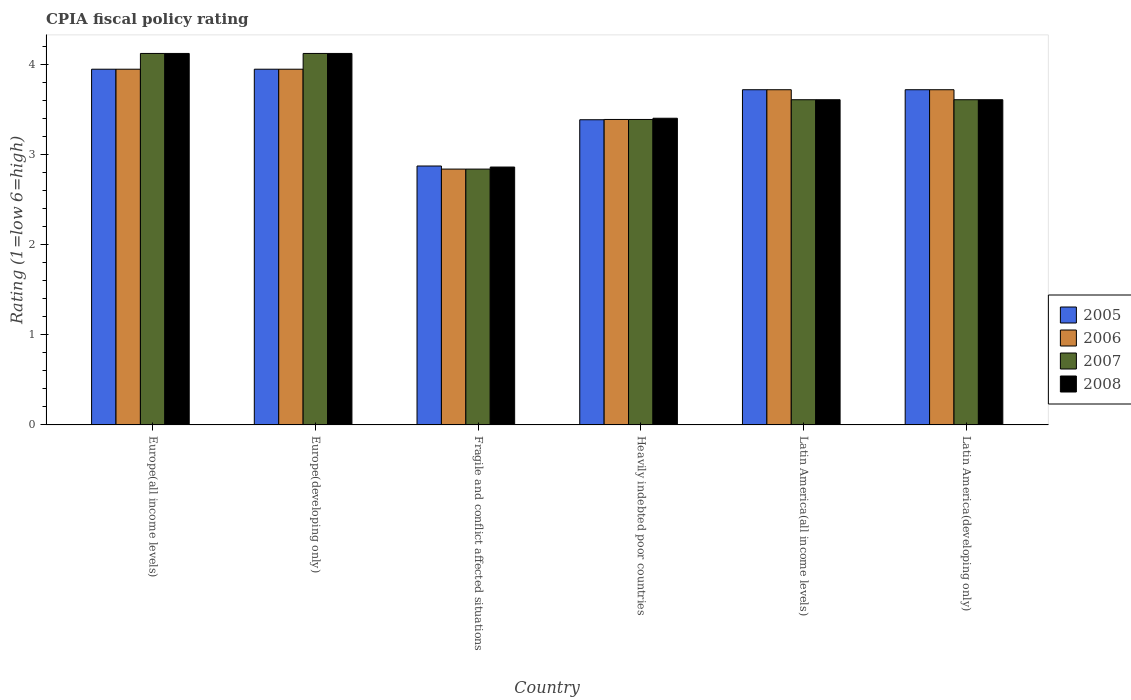How many different coloured bars are there?
Your answer should be very brief. 4. Are the number of bars on each tick of the X-axis equal?
Ensure brevity in your answer.  Yes. How many bars are there on the 4th tick from the left?
Your response must be concise. 4. How many bars are there on the 1st tick from the right?
Your answer should be very brief. 4. What is the label of the 4th group of bars from the left?
Offer a very short reply. Heavily indebted poor countries. What is the CPIA rating in 2006 in Europe(developing only)?
Your answer should be compact. 3.95. Across all countries, what is the maximum CPIA rating in 2008?
Your answer should be compact. 4.12. Across all countries, what is the minimum CPIA rating in 2007?
Offer a very short reply. 2.84. In which country was the CPIA rating in 2007 maximum?
Make the answer very short. Europe(all income levels). In which country was the CPIA rating in 2008 minimum?
Ensure brevity in your answer.  Fragile and conflict affected situations. What is the total CPIA rating in 2008 in the graph?
Ensure brevity in your answer.  21.74. What is the difference between the CPIA rating in 2007 in Fragile and conflict affected situations and that in Heavily indebted poor countries?
Your response must be concise. -0.55. What is the difference between the CPIA rating in 2007 in Latin America(all income levels) and the CPIA rating in 2006 in Heavily indebted poor countries?
Ensure brevity in your answer.  0.22. What is the average CPIA rating in 2007 per country?
Provide a succinct answer. 3.62. What is the difference between the CPIA rating of/in 2006 and CPIA rating of/in 2007 in Latin America(developing only)?
Make the answer very short. 0.11. In how many countries, is the CPIA rating in 2005 greater than 3.6?
Offer a very short reply. 4. What is the ratio of the CPIA rating in 2006 in Europe(all income levels) to that in Latin America(all income levels)?
Provide a short and direct response. 1.06. Is the difference between the CPIA rating in 2006 in Latin America(all income levels) and Latin America(developing only) greater than the difference between the CPIA rating in 2007 in Latin America(all income levels) and Latin America(developing only)?
Your answer should be compact. No. What is the difference between the highest and the second highest CPIA rating in 2006?
Provide a succinct answer. -0.23. What is the difference between the highest and the lowest CPIA rating in 2007?
Your response must be concise. 1.28. In how many countries, is the CPIA rating in 2005 greater than the average CPIA rating in 2005 taken over all countries?
Provide a short and direct response. 4. What does the 3rd bar from the left in Heavily indebted poor countries represents?
Provide a succinct answer. 2007. How many bars are there?
Your response must be concise. 24. Are all the bars in the graph horizontal?
Offer a terse response. No. How many countries are there in the graph?
Ensure brevity in your answer.  6. Where does the legend appear in the graph?
Offer a terse response. Center right. What is the title of the graph?
Ensure brevity in your answer.  CPIA fiscal policy rating. Does "1979" appear as one of the legend labels in the graph?
Make the answer very short. No. What is the label or title of the X-axis?
Your answer should be compact. Country. What is the label or title of the Y-axis?
Provide a succinct answer. Rating (1=low 6=high). What is the Rating (1=low 6=high) of 2005 in Europe(all income levels)?
Your answer should be very brief. 3.95. What is the Rating (1=low 6=high) in 2006 in Europe(all income levels)?
Your response must be concise. 3.95. What is the Rating (1=low 6=high) in 2007 in Europe(all income levels)?
Make the answer very short. 4.12. What is the Rating (1=low 6=high) in 2008 in Europe(all income levels)?
Your response must be concise. 4.12. What is the Rating (1=low 6=high) of 2005 in Europe(developing only)?
Make the answer very short. 3.95. What is the Rating (1=low 6=high) in 2006 in Europe(developing only)?
Ensure brevity in your answer.  3.95. What is the Rating (1=low 6=high) of 2007 in Europe(developing only)?
Ensure brevity in your answer.  4.12. What is the Rating (1=low 6=high) in 2008 in Europe(developing only)?
Provide a short and direct response. 4.12. What is the Rating (1=low 6=high) of 2005 in Fragile and conflict affected situations?
Offer a very short reply. 2.88. What is the Rating (1=low 6=high) of 2006 in Fragile and conflict affected situations?
Provide a succinct answer. 2.84. What is the Rating (1=low 6=high) in 2007 in Fragile and conflict affected situations?
Your answer should be very brief. 2.84. What is the Rating (1=low 6=high) in 2008 in Fragile and conflict affected situations?
Keep it short and to the point. 2.86. What is the Rating (1=low 6=high) of 2005 in Heavily indebted poor countries?
Provide a succinct answer. 3.39. What is the Rating (1=low 6=high) of 2006 in Heavily indebted poor countries?
Your response must be concise. 3.39. What is the Rating (1=low 6=high) of 2007 in Heavily indebted poor countries?
Provide a short and direct response. 3.39. What is the Rating (1=low 6=high) in 2008 in Heavily indebted poor countries?
Your answer should be very brief. 3.41. What is the Rating (1=low 6=high) of 2005 in Latin America(all income levels)?
Ensure brevity in your answer.  3.72. What is the Rating (1=low 6=high) in 2006 in Latin America(all income levels)?
Your response must be concise. 3.72. What is the Rating (1=low 6=high) of 2007 in Latin America(all income levels)?
Your answer should be compact. 3.61. What is the Rating (1=low 6=high) in 2008 in Latin America(all income levels)?
Provide a succinct answer. 3.61. What is the Rating (1=low 6=high) in 2005 in Latin America(developing only)?
Offer a terse response. 3.72. What is the Rating (1=low 6=high) in 2006 in Latin America(developing only)?
Give a very brief answer. 3.72. What is the Rating (1=low 6=high) of 2007 in Latin America(developing only)?
Offer a very short reply. 3.61. What is the Rating (1=low 6=high) of 2008 in Latin America(developing only)?
Your answer should be very brief. 3.61. Across all countries, what is the maximum Rating (1=low 6=high) in 2005?
Provide a short and direct response. 3.95. Across all countries, what is the maximum Rating (1=low 6=high) in 2006?
Your answer should be compact. 3.95. Across all countries, what is the maximum Rating (1=low 6=high) in 2007?
Offer a terse response. 4.12. Across all countries, what is the maximum Rating (1=low 6=high) in 2008?
Keep it short and to the point. 4.12. Across all countries, what is the minimum Rating (1=low 6=high) of 2005?
Give a very brief answer. 2.88. Across all countries, what is the minimum Rating (1=low 6=high) in 2006?
Provide a short and direct response. 2.84. Across all countries, what is the minimum Rating (1=low 6=high) of 2007?
Give a very brief answer. 2.84. Across all countries, what is the minimum Rating (1=low 6=high) of 2008?
Make the answer very short. 2.86. What is the total Rating (1=low 6=high) in 2005 in the graph?
Provide a short and direct response. 21.61. What is the total Rating (1=low 6=high) of 2006 in the graph?
Your answer should be compact. 21.58. What is the total Rating (1=low 6=high) in 2007 in the graph?
Make the answer very short. 21.7. What is the total Rating (1=low 6=high) in 2008 in the graph?
Your response must be concise. 21.74. What is the difference between the Rating (1=low 6=high) of 2006 in Europe(all income levels) and that in Europe(developing only)?
Provide a short and direct response. 0. What is the difference between the Rating (1=low 6=high) of 2007 in Europe(all income levels) and that in Europe(developing only)?
Make the answer very short. 0. What is the difference between the Rating (1=low 6=high) in 2005 in Europe(all income levels) and that in Fragile and conflict affected situations?
Your answer should be very brief. 1.07. What is the difference between the Rating (1=low 6=high) in 2006 in Europe(all income levels) and that in Fragile and conflict affected situations?
Provide a succinct answer. 1.11. What is the difference between the Rating (1=low 6=high) of 2007 in Europe(all income levels) and that in Fragile and conflict affected situations?
Your response must be concise. 1.28. What is the difference between the Rating (1=low 6=high) in 2008 in Europe(all income levels) and that in Fragile and conflict affected situations?
Keep it short and to the point. 1.26. What is the difference between the Rating (1=low 6=high) of 2005 in Europe(all income levels) and that in Heavily indebted poor countries?
Make the answer very short. 0.56. What is the difference between the Rating (1=low 6=high) in 2006 in Europe(all income levels) and that in Heavily indebted poor countries?
Provide a short and direct response. 0.56. What is the difference between the Rating (1=low 6=high) in 2007 in Europe(all income levels) and that in Heavily indebted poor countries?
Give a very brief answer. 0.73. What is the difference between the Rating (1=low 6=high) in 2008 in Europe(all income levels) and that in Heavily indebted poor countries?
Provide a short and direct response. 0.72. What is the difference between the Rating (1=low 6=high) of 2005 in Europe(all income levels) and that in Latin America(all income levels)?
Give a very brief answer. 0.23. What is the difference between the Rating (1=low 6=high) in 2006 in Europe(all income levels) and that in Latin America(all income levels)?
Provide a succinct answer. 0.23. What is the difference between the Rating (1=low 6=high) of 2007 in Europe(all income levels) and that in Latin America(all income levels)?
Your answer should be very brief. 0.51. What is the difference between the Rating (1=low 6=high) in 2008 in Europe(all income levels) and that in Latin America(all income levels)?
Provide a short and direct response. 0.51. What is the difference between the Rating (1=low 6=high) in 2005 in Europe(all income levels) and that in Latin America(developing only)?
Make the answer very short. 0.23. What is the difference between the Rating (1=low 6=high) in 2006 in Europe(all income levels) and that in Latin America(developing only)?
Your answer should be compact. 0.23. What is the difference between the Rating (1=low 6=high) in 2007 in Europe(all income levels) and that in Latin America(developing only)?
Your response must be concise. 0.51. What is the difference between the Rating (1=low 6=high) of 2008 in Europe(all income levels) and that in Latin America(developing only)?
Ensure brevity in your answer.  0.51. What is the difference between the Rating (1=low 6=high) of 2005 in Europe(developing only) and that in Fragile and conflict affected situations?
Make the answer very short. 1.07. What is the difference between the Rating (1=low 6=high) in 2006 in Europe(developing only) and that in Fragile and conflict affected situations?
Ensure brevity in your answer.  1.11. What is the difference between the Rating (1=low 6=high) in 2007 in Europe(developing only) and that in Fragile and conflict affected situations?
Give a very brief answer. 1.28. What is the difference between the Rating (1=low 6=high) of 2008 in Europe(developing only) and that in Fragile and conflict affected situations?
Offer a terse response. 1.26. What is the difference between the Rating (1=low 6=high) of 2005 in Europe(developing only) and that in Heavily indebted poor countries?
Give a very brief answer. 0.56. What is the difference between the Rating (1=low 6=high) in 2006 in Europe(developing only) and that in Heavily indebted poor countries?
Ensure brevity in your answer.  0.56. What is the difference between the Rating (1=low 6=high) in 2007 in Europe(developing only) and that in Heavily indebted poor countries?
Offer a terse response. 0.73. What is the difference between the Rating (1=low 6=high) in 2008 in Europe(developing only) and that in Heavily indebted poor countries?
Give a very brief answer. 0.72. What is the difference between the Rating (1=low 6=high) of 2005 in Europe(developing only) and that in Latin America(all income levels)?
Provide a short and direct response. 0.23. What is the difference between the Rating (1=low 6=high) in 2006 in Europe(developing only) and that in Latin America(all income levels)?
Ensure brevity in your answer.  0.23. What is the difference between the Rating (1=low 6=high) of 2007 in Europe(developing only) and that in Latin America(all income levels)?
Offer a very short reply. 0.51. What is the difference between the Rating (1=low 6=high) in 2008 in Europe(developing only) and that in Latin America(all income levels)?
Ensure brevity in your answer.  0.51. What is the difference between the Rating (1=low 6=high) in 2005 in Europe(developing only) and that in Latin America(developing only)?
Ensure brevity in your answer.  0.23. What is the difference between the Rating (1=low 6=high) in 2006 in Europe(developing only) and that in Latin America(developing only)?
Give a very brief answer. 0.23. What is the difference between the Rating (1=low 6=high) of 2007 in Europe(developing only) and that in Latin America(developing only)?
Your answer should be compact. 0.51. What is the difference between the Rating (1=low 6=high) of 2008 in Europe(developing only) and that in Latin America(developing only)?
Your answer should be compact. 0.51. What is the difference between the Rating (1=low 6=high) in 2005 in Fragile and conflict affected situations and that in Heavily indebted poor countries?
Provide a short and direct response. -0.51. What is the difference between the Rating (1=low 6=high) in 2006 in Fragile and conflict affected situations and that in Heavily indebted poor countries?
Offer a very short reply. -0.55. What is the difference between the Rating (1=low 6=high) of 2007 in Fragile and conflict affected situations and that in Heavily indebted poor countries?
Provide a succinct answer. -0.55. What is the difference between the Rating (1=low 6=high) in 2008 in Fragile and conflict affected situations and that in Heavily indebted poor countries?
Make the answer very short. -0.54. What is the difference between the Rating (1=low 6=high) of 2005 in Fragile and conflict affected situations and that in Latin America(all income levels)?
Your answer should be compact. -0.85. What is the difference between the Rating (1=low 6=high) of 2006 in Fragile and conflict affected situations and that in Latin America(all income levels)?
Give a very brief answer. -0.88. What is the difference between the Rating (1=low 6=high) in 2007 in Fragile and conflict affected situations and that in Latin America(all income levels)?
Your answer should be very brief. -0.77. What is the difference between the Rating (1=low 6=high) of 2008 in Fragile and conflict affected situations and that in Latin America(all income levels)?
Provide a succinct answer. -0.75. What is the difference between the Rating (1=low 6=high) in 2005 in Fragile and conflict affected situations and that in Latin America(developing only)?
Keep it short and to the point. -0.85. What is the difference between the Rating (1=low 6=high) in 2006 in Fragile and conflict affected situations and that in Latin America(developing only)?
Your answer should be very brief. -0.88. What is the difference between the Rating (1=low 6=high) of 2007 in Fragile and conflict affected situations and that in Latin America(developing only)?
Your answer should be very brief. -0.77. What is the difference between the Rating (1=low 6=high) in 2008 in Fragile and conflict affected situations and that in Latin America(developing only)?
Your response must be concise. -0.75. What is the difference between the Rating (1=low 6=high) in 2005 in Heavily indebted poor countries and that in Latin America(all income levels)?
Your answer should be very brief. -0.33. What is the difference between the Rating (1=low 6=high) in 2006 in Heavily indebted poor countries and that in Latin America(all income levels)?
Give a very brief answer. -0.33. What is the difference between the Rating (1=low 6=high) in 2007 in Heavily indebted poor countries and that in Latin America(all income levels)?
Ensure brevity in your answer.  -0.22. What is the difference between the Rating (1=low 6=high) of 2008 in Heavily indebted poor countries and that in Latin America(all income levels)?
Keep it short and to the point. -0.21. What is the difference between the Rating (1=low 6=high) of 2005 in Heavily indebted poor countries and that in Latin America(developing only)?
Offer a very short reply. -0.33. What is the difference between the Rating (1=low 6=high) in 2006 in Heavily indebted poor countries and that in Latin America(developing only)?
Keep it short and to the point. -0.33. What is the difference between the Rating (1=low 6=high) in 2007 in Heavily indebted poor countries and that in Latin America(developing only)?
Your answer should be very brief. -0.22. What is the difference between the Rating (1=low 6=high) of 2008 in Heavily indebted poor countries and that in Latin America(developing only)?
Give a very brief answer. -0.21. What is the difference between the Rating (1=low 6=high) of 2005 in Latin America(all income levels) and that in Latin America(developing only)?
Provide a succinct answer. 0. What is the difference between the Rating (1=low 6=high) in 2008 in Latin America(all income levels) and that in Latin America(developing only)?
Provide a short and direct response. 0. What is the difference between the Rating (1=low 6=high) in 2005 in Europe(all income levels) and the Rating (1=low 6=high) in 2006 in Europe(developing only)?
Offer a very short reply. 0. What is the difference between the Rating (1=low 6=high) of 2005 in Europe(all income levels) and the Rating (1=low 6=high) of 2007 in Europe(developing only)?
Your answer should be very brief. -0.17. What is the difference between the Rating (1=low 6=high) in 2005 in Europe(all income levels) and the Rating (1=low 6=high) in 2008 in Europe(developing only)?
Provide a short and direct response. -0.17. What is the difference between the Rating (1=low 6=high) in 2006 in Europe(all income levels) and the Rating (1=low 6=high) in 2007 in Europe(developing only)?
Offer a very short reply. -0.17. What is the difference between the Rating (1=low 6=high) of 2006 in Europe(all income levels) and the Rating (1=low 6=high) of 2008 in Europe(developing only)?
Make the answer very short. -0.17. What is the difference between the Rating (1=low 6=high) in 2005 in Europe(all income levels) and the Rating (1=low 6=high) in 2006 in Fragile and conflict affected situations?
Ensure brevity in your answer.  1.11. What is the difference between the Rating (1=low 6=high) of 2005 in Europe(all income levels) and the Rating (1=low 6=high) of 2007 in Fragile and conflict affected situations?
Your response must be concise. 1.11. What is the difference between the Rating (1=low 6=high) of 2005 in Europe(all income levels) and the Rating (1=low 6=high) of 2008 in Fragile and conflict affected situations?
Provide a succinct answer. 1.09. What is the difference between the Rating (1=low 6=high) in 2006 in Europe(all income levels) and the Rating (1=low 6=high) in 2007 in Fragile and conflict affected situations?
Ensure brevity in your answer.  1.11. What is the difference between the Rating (1=low 6=high) of 2006 in Europe(all income levels) and the Rating (1=low 6=high) of 2008 in Fragile and conflict affected situations?
Provide a short and direct response. 1.09. What is the difference between the Rating (1=low 6=high) in 2007 in Europe(all income levels) and the Rating (1=low 6=high) in 2008 in Fragile and conflict affected situations?
Keep it short and to the point. 1.26. What is the difference between the Rating (1=low 6=high) of 2005 in Europe(all income levels) and the Rating (1=low 6=high) of 2006 in Heavily indebted poor countries?
Your response must be concise. 0.56. What is the difference between the Rating (1=low 6=high) of 2005 in Europe(all income levels) and the Rating (1=low 6=high) of 2007 in Heavily indebted poor countries?
Offer a terse response. 0.56. What is the difference between the Rating (1=low 6=high) of 2005 in Europe(all income levels) and the Rating (1=low 6=high) of 2008 in Heavily indebted poor countries?
Offer a terse response. 0.54. What is the difference between the Rating (1=low 6=high) of 2006 in Europe(all income levels) and the Rating (1=low 6=high) of 2007 in Heavily indebted poor countries?
Give a very brief answer. 0.56. What is the difference between the Rating (1=low 6=high) of 2006 in Europe(all income levels) and the Rating (1=low 6=high) of 2008 in Heavily indebted poor countries?
Offer a very short reply. 0.54. What is the difference between the Rating (1=low 6=high) of 2007 in Europe(all income levels) and the Rating (1=low 6=high) of 2008 in Heavily indebted poor countries?
Give a very brief answer. 0.72. What is the difference between the Rating (1=low 6=high) of 2005 in Europe(all income levels) and the Rating (1=low 6=high) of 2006 in Latin America(all income levels)?
Your answer should be compact. 0.23. What is the difference between the Rating (1=low 6=high) in 2005 in Europe(all income levels) and the Rating (1=low 6=high) in 2007 in Latin America(all income levels)?
Your answer should be very brief. 0.34. What is the difference between the Rating (1=low 6=high) of 2005 in Europe(all income levels) and the Rating (1=low 6=high) of 2008 in Latin America(all income levels)?
Provide a succinct answer. 0.34. What is the difference between the Rating (1=low 6=high) in 2006 in Europe(all income levels) and the Rating (1=low 6=high) in 2007 in Latin America(all income levels)?
Provide a succinct answer. 0.34. What is the difference between the Rating (1=low 6=high) of 2006 in Europe(all income levels) and the Rating (1=low 6=high) of 2008 in Latin America(all income levels)?
Your answer should be very brief. 0.34. What is the difference between the Rating (1=low 6=high) of 2007 in Europe(all income levels) and the Rating (1=low 6=high) of 2008 in Latin America(all income levels)?
Your answer should be compact. 0.51. What is the difference between the Rating (1=low 6=high) of 2005 in Europe(all income levels) and the Rating (1=low 6=high) of 2006 in Latin America(developing only)?
Offer a terse response. 0.23. What is the difference between the Rating (1=low 6=high) in 2005 in Europe(all income levels) and the Rating (1=low 6=high) in 2007 in Latin America(developing only)?
Give a very brief answer. 0.34. What is the difference between the Rating (1=low 6=high) of 2005 in Europe(all income levels) and the Rating (1=low 6=high) of 2008 in Latin America(developing only)?
Offer a terse response. 0.34. What is the difference between the Rating (1=low 6=high) in 2006 in Europe(all income levels) and the Rating (1=low 6=high) in 2007 in Latin America(developing only)?
Ensure brevity in your answer.  0.34. What is the difference between the Rating (1=low 6=high) in 2006 in Europe(all income levels) and the Rating (1=low 6=high) in 2008 in Latin America(developing only)?
Provide a short and direct response. 0.34. What is the difference between the Rating (1=low 6=high) of 2007 in Europe(all income levels) and the Rating (1=low 6=high) of 2008 in Latin America(developing only)?
Provide a succinct answer. 0.51. What is the difference between the Rating (1=low 6=high) of 2005 in Europe(developing only) and the Rating (1=low 6=high) of 2006 in Fragile and conflict affected situations?
Make the answer very short. 1.11. What is the difference between the Rating (1=low 6=high) in 2005 in Europe(developing only) and the Rating (1=low 6=high) in 2007 in Fragile and conflict affected situations?
Offer a very short reply. 1.11. What is the difference between the Rating (1=low 6=high) in 2005 in Europe(developing only) and the Rating (1=low 6=high) in 2008 in Fragile and conflict affected situations?
Keep it short and to the point. 1.09. What is the difference between the Rating (1=low 6=high) of 2006 in Europe(developing only) and the Rating (1=low 6=high) of 2007 in Fragile and conflict affected situations?
Ensure brevity in your answer.  1.11. What is the difference between the Rating (1=low 6=high) in 2006 in Europe(developing only) and the Rating (1=low 6=high) in 2008 in Fragile and conflict affected situations?
Provide a short and direct response. 1.09. What is the difference between the Rating (1=low 6=high) in 2007 in Europe(developing only) and the Rating (1=low 6=high) in 2008 in Fragile and conflict affected situations?
Offer a terse response. 1.26. What is the difference between the Rating (1=low 6=high) of 2005 in Europe(developing only) and the Rating (1=low 6=high) of 2006 in Heavily indebted poor countries?
Make the answer very short. 0.56. What is the difference between the Rating (1=low 6=high) in 2005 in Europe(developing only) and the Rating (1=low 6=high) in 2007 in Heavily indebted poor countries?
Your answer should be very brief. 0.56. What is the difference between the Rating (1=low 6=high) in 2005 in Europe(developing only) and the Rating (1=low 6=high) in 2008 in Heavily indebted poor countries?
Your response must be concise. 0.54. What is the difference between the Rating (1=low 6=high) of 2006 in Europe(developing only) and the Rating (1=low 6=high) of 2007 in Heavily indebted poor countries?
Your answer should be compact. 0.56. What is the difference between the Rating (1=low 6=high) of 2006 in Europe(developing only) and the Rating (1=low 6=high) of 2008 in Heavily indebted poor countries?
Provide a short and direct response. 0.54. What is the difference between the Rating (1=low 6=high) of 2007 in Europe(developing only) and the Rating (1=low 6=high) of 2008 in Heavily indebted poor countries?
Your answer should be compact. 0.72. What is the difference between the Rating (1=low 6=high) of 2005 in Europe(developing only) and the Rating (1=low 6=high) of 2006 in Latin America(all income levels)?
Offer a very short reply. 0.23. What is the difference between the Rating (1=low 6=high) of 2005 in Europe(developing only) and the Rating (1=low 6=high) of 2007 in Latin America(all income levels)?
Provide a succinct answer. 0.34. What is the difference between the Rating (1=low 6=high) of 2005 in Europe(developing only) and the Rating (1=low 6=high) of 2008 in Latin America(all income levels)?
Your answer should be very brief. 0.34. What is the difference between the Rating (1=low 6=high) of 2006 in Europe(developing only) and the Rating (1=low 6=high) of 2007 in Latin America(all income levels)?
Offer a very short reply. 0.34. What is the difference between the Rating (1=low 6=high) in 2006 in Europe(developing only) and the Rating (1=low 6=high) in 2008 in Latin America(all income levels)?
Offer a very short reply. 0.34. What is the difference between the Rating (1=low 6=high) in 2007 in Europe(developing only) and the Rating (1=low 6=high) in 2008 in Latin America(all income levels)?
Provide a succinct answer. 0.51. What is the difference between the Rating (1=low 6=high) in 2005 in Europe(developing only) and the Rating (1=low 6=high) in 2006 in Latin America(developing only)?
Give a very brief answer. 0.23. What is the difference between the Rating (1=low 6=high) in 2005 in Europe(developing only) and the Rating (1=low 6=high) in 2007 in Latin America(developing only)?
Ensure brevity in your answer.  0.34. What is the difference between the Rating (1=low 6=high) of 2005 in Europe(developing only) and the Rating (1=low 6=high) of 2008 in Latin America(developing only)?
Provide a succinct answer. 0.34. What is the difference between the Rating (1=low 6=high) of 2006 in Europe(developing only) and the Rating (1=low 6=high) of 2007 in Latin America(developing only)?
Make the answer very short. 0.34. What is the difference between the Rating (1=low 6=high) in 2006 in Europe(developing only) and the Rating (1=low 6=high) in 2008 in Latin America(developing only)?
Ensure brevity in your answer.  0.34. What is the difference between the Rating (1=low 6=high) in 2007 in Europe(developing only) and the Rating (1=low 6=high) in 2008 in Latin America(developing only)?
Give a very brief answer. 0.51. What is the difference between the Rating (1=low 6=high) in 2005 in Fragile and conflict affected situations and the Rating (1=low 6=high) in 2006 in Heavily indebted poor countries?
Your answer should be very brief. -0.52. What is the difference between the Rating (1=low 6=high) in 2005 in Fragile and conflict affected situations and the Rating (1=low 6=high) in 2007 in Heavily indebted poor countries?
Give a very brief answer. -0.52. What is the difference between the Rating (1=low 6=high) of 2005 in Fragile and conflict affected situations and the Rating (1=low 6=high) of 2008 in Heavily indebted poor countries?
Provide a succinct answer. -0.53. What is the difference between the Rating (1=low 6=high) in 2006 in Fragile and conflict affected situations and the Rating (1=low 6=high) in 2007 in Heavily indebted poor countries?
Provide a short and direct response. -0.55. What is the difference between the Rating (1=low 6=high) in 2006 in Fragile and conflict affected situations and the Rating (1=low 6=high) in 2008 in Heavily indebted poor countries?
Offer a very short reply. -0.56. What is the difference between the Rating (1=low 6=high) of 2007 in Fragile and conflict affected situations and the Rating (1=low 6=high) of 2008 in Heavily indebted poor countries?
Make the answer very short. -0.56. What is the difference between the Rating (1=low 6=high) in 2005 in Fragile and conflict affected situations and the Rating (1=low 6=high) in 2006 in Latin America(all income levels)?
Offer a terse response. -0.85. What is the difference between the Rating (1=low 6=high) in 2005 in Fragile and conflict affected situations and the Rating (1=low 6=high) in 2007 in Latin America(all income levels)?
Your answer should be very brief. -0.74. What is the difference between the Rating (1=low 6=high) of 2005 in Fragile and conflict affected situations and the Rating (1=low 6=high) of 2008 in Latin America(all income levels)?
Your answer should be very brief. -0.74. What is the difference between the Rating (1=low 6=high) of 2006 in Fragile and conflict affected situations and the Rating (1=low 6=high) of 2007 in Latin America(all income levels)?
Give a very brief answer. -0.77. What is the difference between the Rating (1=low 6=high) of 2006 in Fragile and conflict affected situations and the Rating (1=low 6=high) of 2008 in Latin America(all income levels)?
Provide a short and direct response. -0.77. What is the difference between the Rating (1=low 6=high) of 2007 in Fragile and conflict affected situations and the Rating (1=low 6=high) of 2008 in Latin America(all income levels)?
Your answer should be very brief. -0.77. What is the difference between the Rating (1=low 6=high) in 2005 in Fragile and conflict affected situations and the Rating (1=low 6=high) in 2006 in Latin America(developing only)?
Make the answer very short. -0.85. What is the difference between the Rating (1=low 6=high) in 2005 in Fragile and conflict affected situations and the Rating (1=low 6=high) in 2007 in Latin America(developing only)?
Your answer should be compact. -0.74. What is the difference between the Rating (1=low 6=high) of 2005 in Fragile and conflict affected situations and the Rating (1=low 6=high) of 2008 in Latin America(developing only)?
Provide a succinct answer. -0.74. What is the difference between the Rating (1=low 6=high) in 2006 in Fragile and conflict affected situations and the Rating (1=low 6=high) in 2007 in Latin America(developing only)?
Give a very brief answer. -0.77. What is the difference between the Rating (1=low 6=high) in 2006 in Fragile and conflict affected situations and the Rating (1=low 6=high) in 2008 in Latin America(developing only)?
Provide a succinct answer. -0.77. What is the difference between the Rating (1=low 6=high) in 2007 in Fragile and conflict affected situations and the Rating (1=low 6=high) in 2008 in Latin America(developing only)?
Provide a succinct answer. -0.77. What is the difference between the Rating (1=low 6=high) in 2005 in Heavily indebted poor countries and the Rating (1=low 6=high) in 2007 in Latin America(all income levels)?
Ensure brevity in your answer.  -0.22. What is the difference between the Rating (1=low 6=high) of 2005 in Heavily indebted poor countries and the Rating (1=low 6=high) of 2008 in Latin America(all income levels)?
Offer a very short reply. -0.22. What is the difference between the Rating (1=low 6=high) of 2006 in Heavily indebted poor countries and the Rating (1=low 6=high) of 2007 in Latin America(all income levels)?
Ensure brevity in your answer.  -0.22. What is the difference between the Rating (1=low 6=high) of 2006 in Heavily indebted poor countries and the Rating (1=low 6=high) of 2008 in Latin America(all income levels)?
Ensure brevity in your answer.  -0.22. What is the difference between the Rating (1=low 6=high) of 2007 in Heavily indebted poor countries and the Rating (1=low 6=high) of 2008 in Latin America(all income levels)?
Your answer should be very brief. -0.22. What is the difference between the Rating (1=low 6=high) in 2005 in Heavily indebted poor countries and the Rating (1=low 6=high) in 2006 in Latin America(developing only)?
Your answer should be compact. -0.33. What is the difference between the Rating (1=low 6=high) of 2005 in Heavily indebted poor countries and the Rating (1=low 6=high) of 2007 in Latin America(developing only)?
Your answer should be compact. -0.22. What is the difference between the Rating (1=low 6=high) of 2005 in Heavily indebted poor countries and the Rating (1=low 6=high) of 2008 in Latin America(developing only)?
Offer a very short reply. -0.22. What is the difference between the Rating (1=low 6=high) of 2006 in Heavily indebted poor countries and the Rating (1=low 6=high) of 2007 in Latin America(developing only)?
Give a very brief answer. -0.22. What is the difference between the Rating (1=low 6=high) in 2006 in Heavily indebted poor countries and the Rating (1=low 6=high) in 2008 in Latin America(developing only)?
Your response must be concise. -0.22. What is the difference between the Rating (1=low 6=high) in 2007 in Heavily indebted poor countries and the Rating (1=low 6=high) in 2008 in Latin America(developing only)?
Provide a succinct answer. -0.22. What is the difference between the Rating (1=low 6=high) of 2005 in Latin America(all income levels) and the Rating (1=low 6=high) of 2007 in Latin America(developing only)?
Ensure brevity in your answer.  0.11. What is the difference between the Rating (1=low 6=high) of 2006 in Latin America(all income levels) and the Rating (1=low 6=high) of 2007 in Latin America(developing only)?
Offer a terse response. 0.11. What is the average Rating (1=low 6=high) in 2005 per country?
Your answer should be compact. 3.6. What is the average Rating (1=low 6=high) of 2006 per country?
Provide a succinct answer. 3.6. What is the average Rating (1=low 6=high) of 2007 per country?
Make the answer very short. 3.62. What is the average Rating (1=low 6=high) of 2008 per country?
Your response must be concise. 3.62. What is the difference between the Rating (1=low 6=high) of 2005 and Rating (1=low 6=high) of 2007 in Europe(all income levels)?
Keep it short and to the point. -0.17. What is the difference between the Rating (1=low 6=high) in 2005 and Rating (1=low 6=high) in 2008 in Europe(all income levels)?
Ensure brevity in your answer.  -0.17. What is the difference between the Rating (1=low 6=high) in 2006 and Rating (1=low 6=high) in 2007 in Europe(all income levels)?
Your answer should be very brief. -0.17. What is the difference between the Rating (1=low 6=high) in 2006 and Rating (1=low 6=high) in 2008 in Europe(all income levels)?
Your answer should be very brief. -0.17. What is the difference between the Rating (1=low 6=high) in 2005 and Rating (1=low 6=high) in 2006 in Europe(developing only)?
Give a very brief answer. 0. What is the difference between the Rating (1=low 6=high) of 2005 and Rating (1=low 6=high) of 2007 in Europe(developing only)?
Offer a very short reply. -0.17. What is the difference between the Rating (1=low 6=high) of 2005 and Rating (1=low 6=high) of 2008 in Europe(developing only)?
Make the answer very short. -0.17. What is the difference between the Rating (1=low 6=high) in 2006 and Rating (1=low 6=high) in 2007 in Europe(developing only)?
Make the answer very short. -0.17. What is the difference between the Rating (1=low 6=high) in 2006 and Rating (1=low 6=high) in 2008 in Europe(developing only)?
Give a very brief answer. -0.17. What is the difference between the Rating (1=low 6=high) in 2007 and Rating (1=low 6=high) in 2008 in Europe(developing only)?
Provide a succinct answer. 0. What is the difference between the Rating (1=low 6=high) of 2005 and Rating (1=low 6=high) of 2006 in Fragile and conflict affected situations?
Your answer should be very brief. 0.03. What is the difference between the Rating (1=low 6=high) of 2005 and Rating (1=low 6=high) of 2007 in Fragile and conflict affected situations?
Provide a short and direct response. 0.03. What is the difference between the Rating (1=low 6=high) in 2005 and Rating (1=low 6=high) in 2008 in Fragile and conflict affected situations?
Give a very brief answer. 0.01. What is the difference between the Rating (1=low 6=high) in 2006 and Rating (1=low 6=high) in 2007 in Fragile and conflict affected situations?
Keep it short and to the point. 0. What is the difference between the Rating (1=low 6=high) of 2006 and Rating (1=low 6=high) of 2008 in Fragile and conflict affected situations?
Your answer should be compact. -0.02. What is the difference between the Rating (1=low 6=high) in 2007 and Rating (1=low 6=high) in 2008 in Fragile and conflict affected situations?
Keep it short and to the point. -0.02. What is the difference between the Rating (1=low 6=high) in 2005 and Rating (1=low 6=high) in 2006 in Heavily indebted poor countries?
Offer a terse response. -0. What is the difference between the Rating (1=low 6=high) of 2005 and Rating (1=low 6=high) of 2007 in Heavily indebted poor countries?
Offer a very short reply. -0. What is the difference between the Rating (1=low 6=high) of 2005 and Rating (1=low 6=high) of 2008 in Heavily indebted poor countries?
Ensure brevity in your answer.  -0.02. What is the difference between the Rating (1=low 6=high) in 2006 and Rating (1=low 6=high) in 2008 in Heavily indebted poor countries?
Make the answer very short. -0.01. What is the difference between the Rating (1=low 6=high) in 2007 and Rating (1=low 6=high) in 2008 in Heavily indebted poor countries?
Offer a terse response. -0.01. What is the difference between the Rating (1=low 6=high) of 2005 and Rating (1=low 6=high) of 2006 in Latin America(all income levels)?
Keep it short and to the point. 0. What is the difference between the Rating (1=low 6=high) in 2005 and Rating (1=low 6=high) in 2007 in Latin America(all income levels)?
Your answer should be very brief. 0.11. What is the difference between the Rating (1=low 6=high) of 2005 and Rating (1=low 6=high) of 2008 in Latin America(all income levels)?
Provide a succinct answer. 0.11. What is the difference between the Rating (1=low 6=high) of 2006 and Rating (1=low 6=high) of 2008 in Latin America(all income levels)?
Offer a terse response. 0.11. What is the difference between the Rating (1=low 6=high) in 2007 and Rating (1=low 6=high) in 2008 in Latin America(all income levels)?
Keep it short and to the point. 0. What is the difference between the Rating (1=low 6=high) in 2005 and Rating (1=low 6=high) in 2006 in Latin America(developing only)?
Keep it short and to the point. 0. What is the difference between the Rating (1=low 6=high) in 2006 and Rating (1=low 6=high) in 2007 in Latin America(developing only)?
Provide a short and direct response. 0.11. What is the ratio of the Rating (1=low 6=high) in 2005 in Europe(all income levels) to that in Europe(developing only)?
Give a very brief answer. 1. What is the ratio of the Rating (1=low 6=high) in 2007 in Europe(all income levels) to that in Europe(developing only)?
Your response must be concise. 1. What is the ratio of the Rating (1=low 6=high) of 2005 in Europe(all income levels) to that in Fragile and conflict affected situations?
Your answer should be very brief. 1.37. What is the ratio of the Rating (1=low 6=high) in 2006 in Europe(all income levels) to that in Fragile and conflict affected situations?
Make the answer very short. 1.39. What is the ratio of the Rating (1=low 6=high) in 2007 in Europe(all income levels) to that in Fragile and conflict affected situations?
Provide a short and direct response. 1.45. What is the ratio of the Rating (1=low 6=high) of 2008 in Europe(all income levels) to that in Fragile and conflict affected situations?
Your answer should be very brief. 1.44. What is the ratio of the Rating (1=low 6=high) in 2005 in Europe(all income levels) to that in Heavily indebted poor countries?
Your answer should be compact. 1.17. What is the ratio of the Rating (1=low 6=high) in 2006 in Europe(all income levels) to that in Heavily indebted poor countries?
Your answer should be very brief. 1.16. What is the ratio of the Rating (1=low 6=high) of 2007 in Europe(all income levels) to that in Heavily indebted poor countries?
Provide a short and direct response. 1.22. What is the ratio of the Rating (1=low 6=high) of 2008 in Europe(all income levels) to that in Heavily indebted poor countries?
Ensure brevity in your answer.  1.21. What is the ratio of the Rating (1=low 6=high) in 2005 in Europe(all income levels) to that in Latin America(all income levels)?
Ensure brevity in your answer.  1.06. What is the ratio of the Rating (1=low 6=high) in 2006 in Europe(all income levels) to that in Latin America(all income levels)?
Ensure brevity in your answer.  1.06. What is the ratio of the Rating (1=low 6=high) in 2007 in Europe(all income levels) to that in Latin America(all income levels)?
Your response must be concise. 1.14. What is the ratio of the Rating (1=low 6=high) of 2008 in Europe(all income levels) to that in Latin America(all income levels)?
Your answer should be compact. 1.14. What is the ratio of the Rating (1=low 6=high) in 2005 in Europe(all income levels) to that in Latin America(developing only)?
Your answer should be compact. 1.06. What is the ratio of the Rating (1=low 6=high) of 2006 in Europe(all income levels) to that in Latin America(developing only)?
Ensure brevity in your answer.  1.06. What is the ratio of the Rating (1=low 6=high) of 2007 in Europe(all income levels) to that in Latin America(developing only)?
Your response must be concise. 1.14. What is the ratio of the Rating (1=low 6=high) of 2008 in Europe(all income levels) to that in Latin America(developing only)?
Offer a very short reply. 1.14. What is the ratio of the Rating (1=low 6=high) in 2005 in Europe(developing only) to that in Fragile and conflict affected situations?
Offer a terse response. 1.37. What is the ratio of the Rating (1=low 6=high) in 2006 in Europe(developing only) to that in Fragile and conflict affected situations?
Give a very brief answer. 1.39. What is the ratio of the Rating (1=low 6=high) in 2007 in Europe(developing only) to that in Fragile and conflict affected situations?
Offer a terse response. 1.45. What is the ratio of the Rating (1=low 6=high) of 2008 in Europe(developing only) to that in Fragile and conflict affected situations?
Keep it short and to the point. 1.44. What is the ratio of the Rating (1=low 6=high) in 2005 in Europe(developing only) to that in Heavily indebted poor countries?
Keep it short and to the point. 1.17. What is the ratio of the Rating (1=low 6=high) of 2006 in Europe(developing only) to that in Heavily indebted poor countries?
Your answer should be compact. 1.16. What is the ratio of the Rating (1=low 6=high) in 2007 in Europe(developing only) to that in Heavily indebted poor countries?
Keep it short and to the point. 1.22. What is the ratio of the Rating (1=low 6=high) in 2008 in Europe(developing only) to that in Heavily indebted poor countries?
Make the answer very short. 1.21. What is the ratio of the Rating (1=low 6=high) in 2005 in Europe(developing only) to that in Latin America(all income levels)?
Your answer should be compact. 1.06. What is the ratio of the Rating (1=low 6=high) of 2006 in Europe(developing only) to that in Latin America(all income levels)?
Give a very brief answer. 1.06. What is the ratio of the Rating (1=low 6=high) of 2007 in Europe(developing only) to that in Latin America(all income levels)?
Offer a terse response. 1.14. What is the ratio of the Rating (1=low 6=high) of 2008 in Europe(developing only) to that in Latin America(all income levels)?
Keep it short and to the point. 1.14. What is the ratio of the Rating (1=low 6=high) of 2005 in Europe(developing only) to that in Latin America(developing only)?
Ensure brevity in your answer.  1.06. What is the ratio of the Rating (1=low 6=high) in 2006 in Europe(developing only) to that in Latin America(developing only)?
Offer a very short reply. 1.06. What is the ratio of the Rating (1=low 6=high) in 2007 in Europe(developing only) to that in Latin America(developing only)?
Make the answer very short. 1.14. What is the ratio of the Rating (1=low 6=high) in 2008 in Europe(developing only) to that in Latin America(developing only)?
Provide a short and direct response. 1.14. What is the ratio of the Rating (1=low 6=high) of 2005 in Fragile and conflict affected situations to that in Heavily indebted poor countries?
Your response must be concise. 0.85. What is the ratio of the Rating (1=low 6=high) of 2006 in Fragile and conflict affected situations to that in Heavily indebted poor countries?
Give a very brief answer. 0.84. What is the ratio of the Rating (1=low 6=high) in 2007 in Fragile and conflict affected situations to that in Heavily indebted poor countries?
Offer a very short reply. 0.84. What is the ratio of the Rating (1=low 6=high) in 2008 in Fragile and conflict affected situations to that in Heavily indebted poor countries?
Your answer should be very brief. 0.84. What is the ratio of the Rating (1=low 6=high) of 2005 in Fragile and conflict affected situations to that in Latin America(all income levels)?
Provide a short and direct response. 0.77. What is the ratio of the Rating (1=low 6=high) in 2006 in Fragile and conflict affected situations to that in Latin America(all income levels)?
Ensure brevity in your answer.  0.76. What is the ratio of the Rating (1=low 6=high) of 2007 in Fragile and conflict affected situations to that in Latin America(all income levels)?
Give a very brief answer. 0.79. What is the ratio of the Rating (1=low 6=high) of 2008 in Fragile and conflict affected situations to that in Latin America(all income levels)?
Make the answer very short. 0.79. What is the ratio of the Rating (1=low 6=high) in 2005 in Fragile and conflict affected situations to that in Latin America(developing only)?
Your answer should be very brief. 0.77. What is the ratio of the Rating (1=low 6=high) in 2006 in Fragile and conflict affected situations to that in Latin America(developing only)?
Your answer should be compact. 0.76. What is the ratio of the Rating (1=low 6=high) of 2007 in Fragile and conflict affected situations to that in Latin America(developing only)?
Make the answer very short. 0.79. What is the ratio of the Rating (1=low 6=high) of 2008 in Fragile and conflict affected situations to that in Latin America(developing only)?
Offer a terse response. 0.79. What is the ratio of the Rating (1=low 6=high) of 2005 in Heavily indebted poor countries to that in Latin America(all income levels)?
Provide a succinct answer. 0.91. What is the ratio of the Rating (1=low 6=high) of 2006 in Heavily indebted poor countries to that in Latin America(all income levels)?
Offer a terse response. 0.91. What is the ratio of the Rating (1=low 6=high) of 2007 in Heavily indebted poor countries to that in Latin America(all income levels)?
Provide a short and direct response. 0.94. What is the ratio of the Rating (1=low 6=high) of 2008 in Heavily indebted poor countries to that in Latin America(all income levels)?
Make the answer very short. 0.94. What is the ratio of the Rating (1=low 6=high) in 2005 in Heavily indebted poor countries to that in Latin America(developing only)?
Your answer should be compact. 0.91. What is the ratio of the Rating (1=low 6=high) of 2006 in Heavily indebted poor countries to that in Latin America(developing only)?
Your response must be concise. 0.91. What is the ratio of the Rating (1=low 6=high) of 2007 in Heavily indebted poor countries to that in Latin America(developing only)?
Offer a terse response. 0.94. What is the ratio of the Rating (1=low 6=high) of 2008 in Heavily indebted poor countries to that in Latin America(developing only)?
Keep it short and to the point. 0.94. What is the ratio of the Rating (1=low 6=high) in 2006 in Latin America(all income levels) to that in Latin America(developing only)?
Offer a very short reply. 1. What is the difference between the highest and the lowest Rating (1=low 6=high) of 2005?
Offer a terse response. 1.07. What is the difference between the highest and the lowest Rating (1=low 6=high) in 2006?
Ensure brevity in your answer.  1.11. What is the difference between the highest and the lowest Rating (1=low 6=high) in 2007?
Provide a short and direct response. 1.28. What is the difference between the highest and the lowest Rating (1=low 6=high) in 2008?
Your answer should be compact. 1.26. 